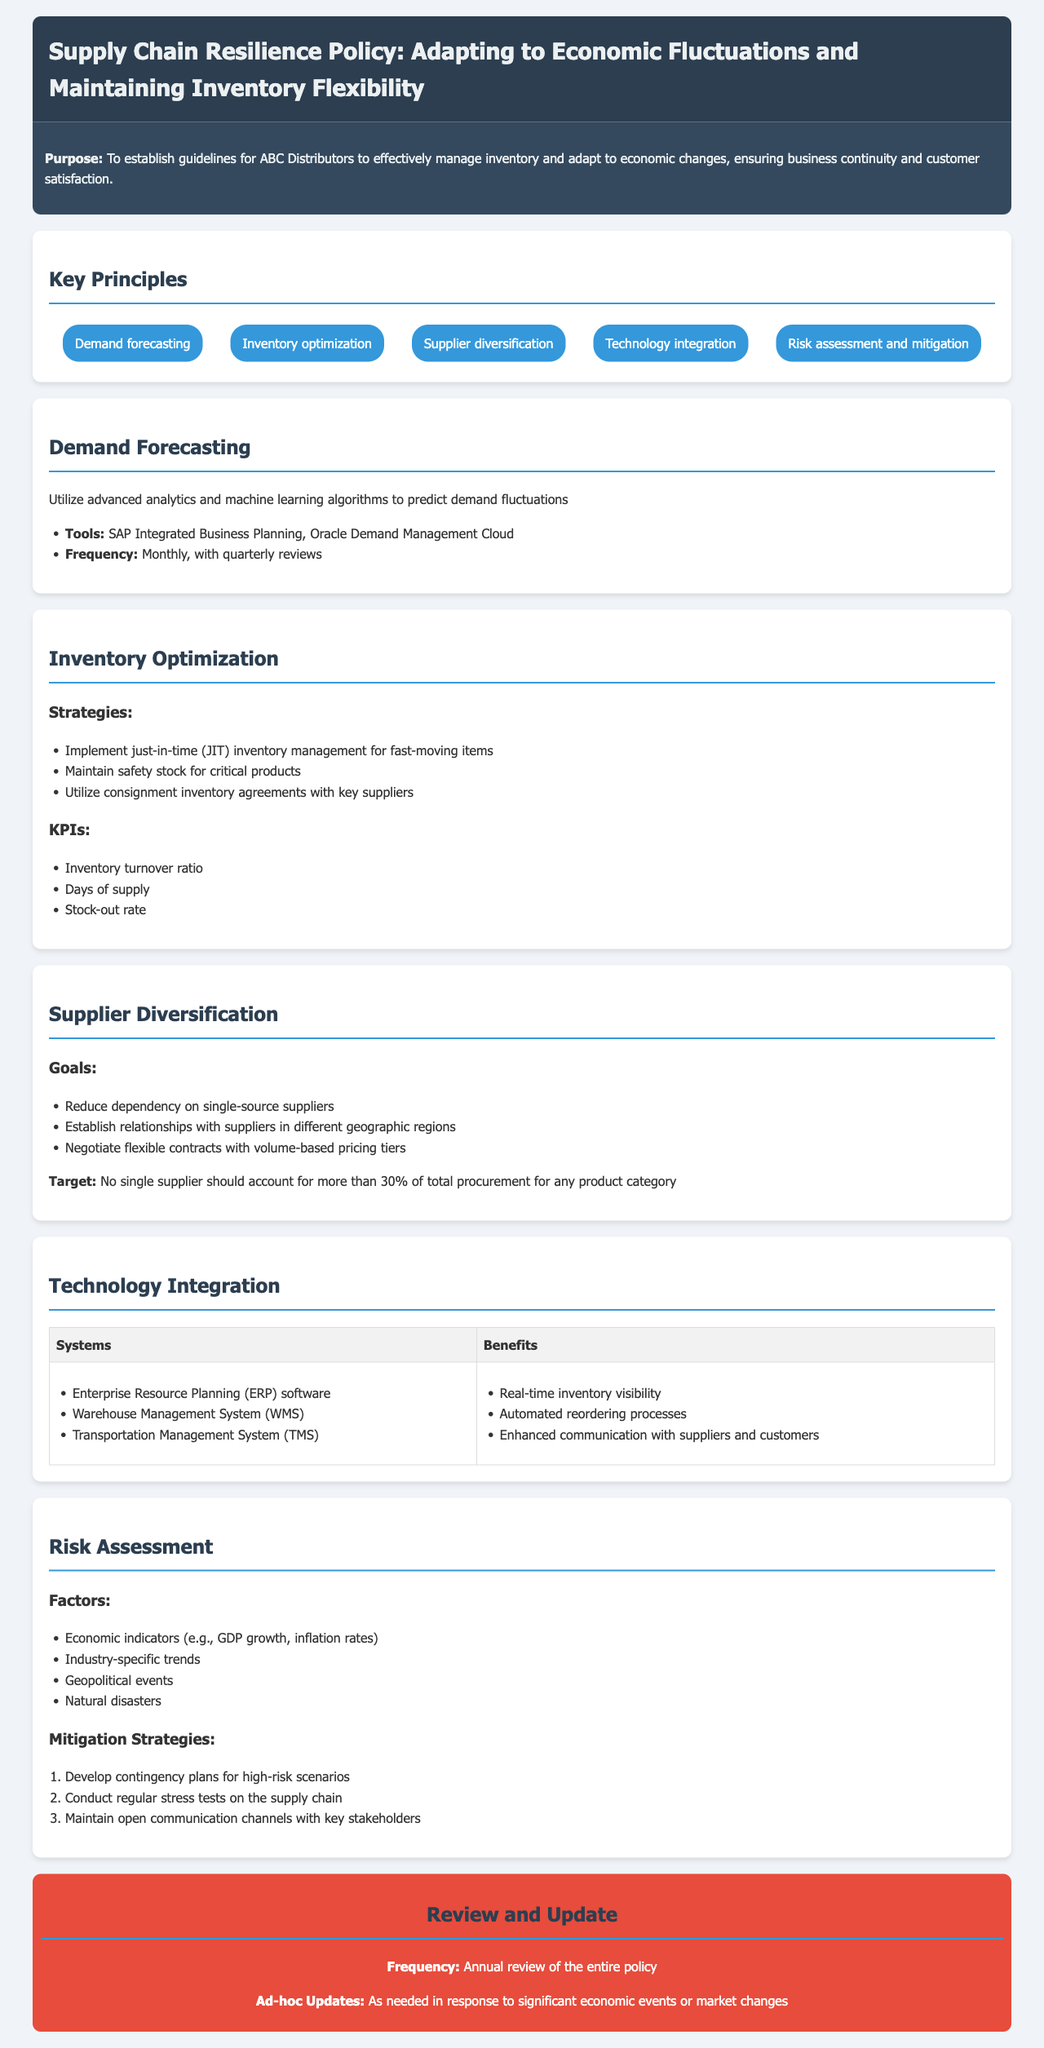What is the purpose of the policy? The purpose is to establish guidelines for ABC Distributors to effectively manage inventory and adapt to economic changes, ensuring business continuity and customer satisfaction.
Answer: To establish guidelines for ABC Distributors to effectively manage inventory and adapt to economic changes, ensuring business continuity and customer satisfaction What is the target percentage for procurement from a single supplier? The document specifies that no single supplier should account for more than 30% of total procurement for any product category.
Answer: 30% How often should demand forecasting be conducted? The frequency of demand forecasting is stated as monthly, with quarterly reviews.
Answer: Monthly, with quarterly reviews What are the three types of systems mentioned under technology integration? The document lists Enterprise Resource Planning (ERP) software, Warehouse Management System (WMS), and Transportation Management System (TMS) as the three types of systems.
Answer: ERP software, WMS, TMS What strategy is suggested for fast-moving items in inventory optimization? The policy recommends implementing just-in-time (JIT) inventory management for fast-moving items.
Answer: Just-in-time (JIT) inventory management What are the two main factors considered in risk assessment? The document indicates that economic indicators and industry-specific trends are two of the main factors in risk assessment.
Answer: Economic indicators, industry-specific trends How often is the entire policy reviewed? The policy states that there will be an annual review of the entire document.
Answer: Annual review What is one of the risks that should be regularly tested in the supply chain? Regular stress tests on the supply chain are recommended to assess potential risks.
Answer: Stress tests on the supply chain 